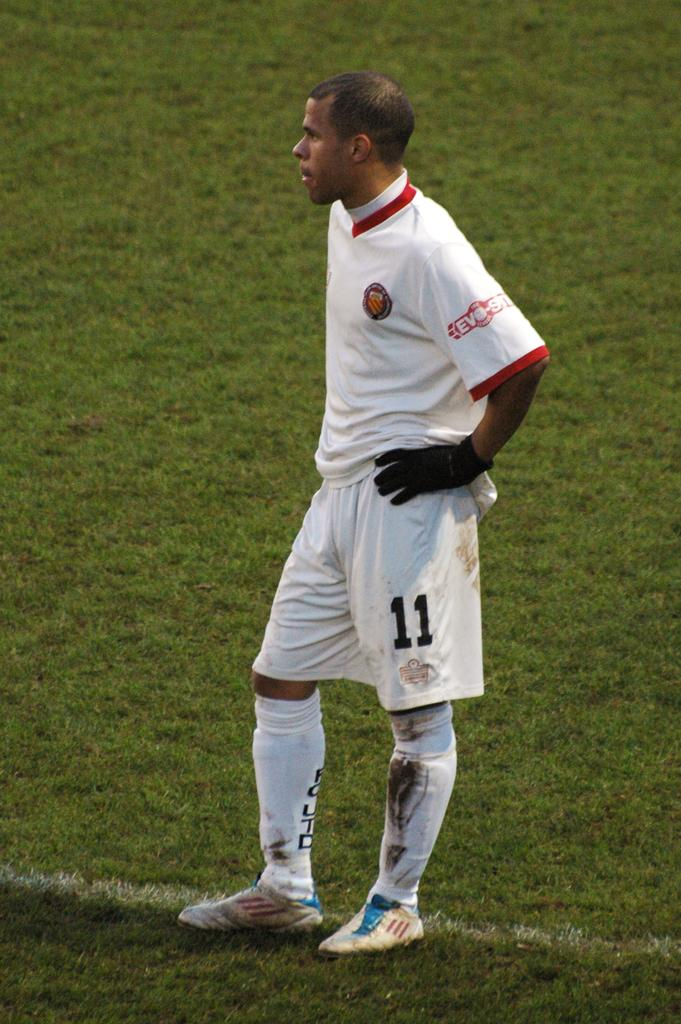<image>
Provide a brief description of the given image. a player with the number 11 on their shorts 